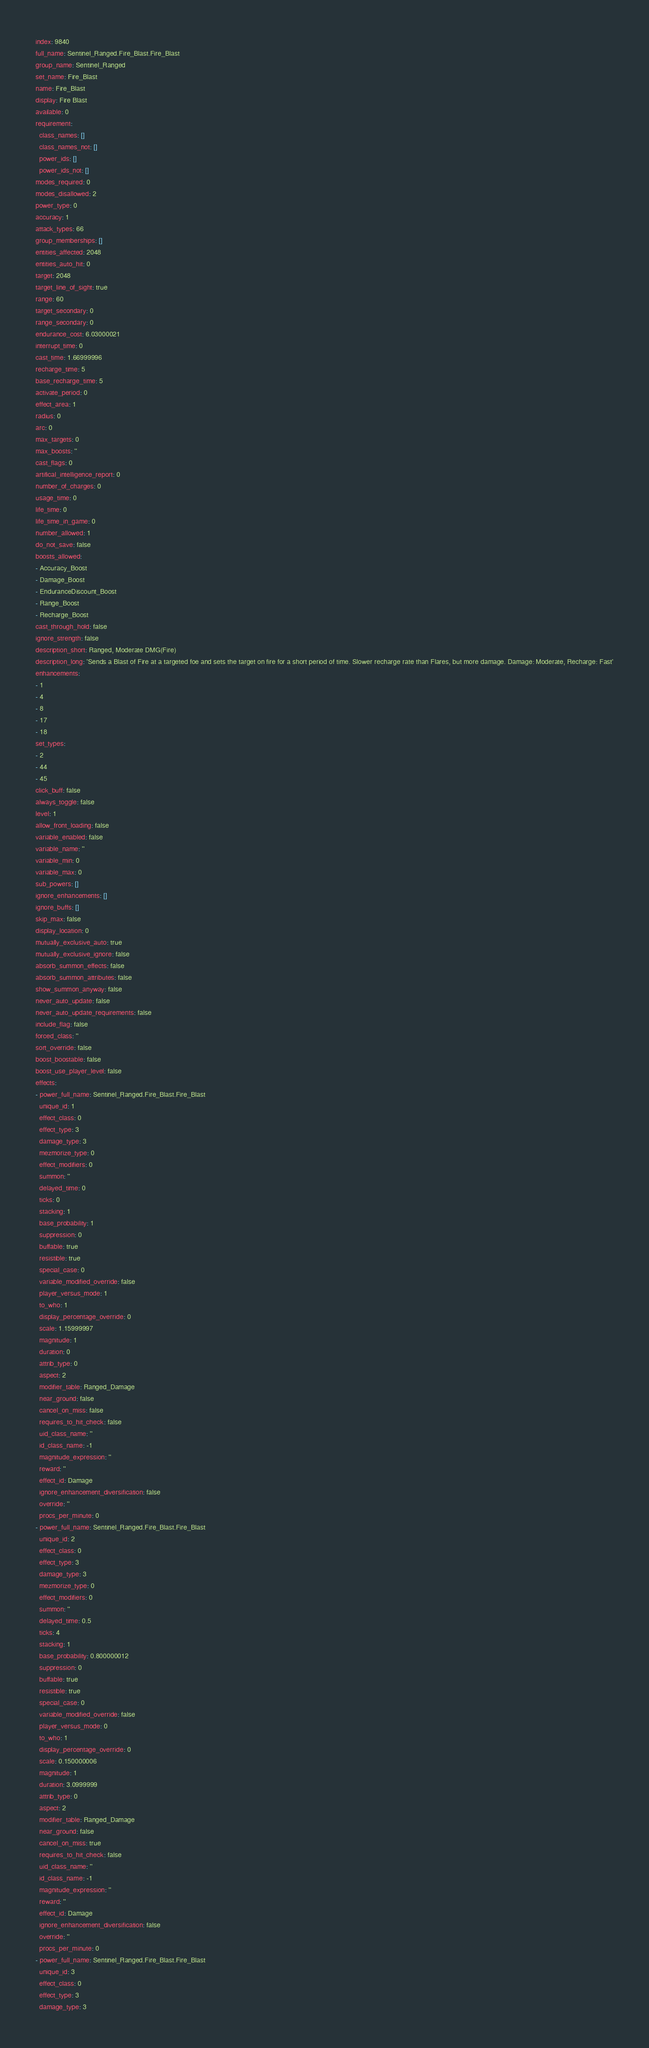Convert code to text. <code><loc_0><loc_0><loc_500><loc_500><_YAML_>index: 9840
full_name: Sentinel_Ranged.Fire_Blast.Fire_Blast
group_name: Sentinel_Ranged
set_name: Fire_Blast
name: Fire_Blast
display: Fire Blast
available: 0
requirement:
  class_names: []
  class_names_not: []
  power_ids: []
  power_ids_not: []
modes_required: 0
modes_disallowed: 2
power_type: 0
accuracy: 1
attack_types: 66
group_memberships: []
entities_affected: 2048
entities_auto_hit: 0
target: 2048
target_line_of_sight: true
range: 60
target_secondary: 0
range_secondary: 0
endurance_cost: 6.03000021
interrupt_time: 0
cast_time: 1.66999996
recharge_time: 5
base_recharge_time: 5
activate_period: 0
effect_area: 1
radius: 0
arc: 0
max_targets: 0
max_boosts: ''
cast_flags: 0
artifical_intelligence_report: 0
number_of_charges: 0
usage_time: 0
life_time: 0
life_time_in_game: 0
number_allowed: 1
do_not_save: false
boosts_allowed:
- Accuracy_Boost
- Damage_Boost
- EnduranceDiscount_Boost
- Range_Boost
- Recharge_Boost
cast_through_hold: false
ignore_strength: false
description_short: Ranged, Moderate DMG(Fire)
description_long: 'Sends a Blast of Fire at a targeted foe and sets the target on fire for a short period of time. Slower recharge rate than Flares, but more damage. Damage: Moderate, Recharge: Fast'
enhancements:
- 1
- 4
- 8
- 17
- 18
set_types:
- 2
- 44
- 45
click_buff: false
always_toggle: false
level: 1
allow_front_loading: false
variable_enabled: false
variable_name: ''
variable_min: 0
variable_max: 0
sub_powers: []
ignore_enhancements: []
ignore_buffs: []
skip_max: false
display_location: 0
mutually_exclusive_auto: true
mutually_exclusive_ignore: false
absorb_summon_effects: false
absorb_summon_attributes: false
show_summon_anyway: false
never_auto_update: false
never_auto_update_requirements: false
include_flag: false
forced_class: ''
sort_override: false
boost_boostable: false
boost_use_player_level: false
effects:
- power_full_name: Sentinel_Ranged.Fire_Blast.Fire_Blast
  unique_id: 1
  effect_class: 0
  effect_type: 3
  damage_type: 3
  mezmorize_type: 0
  effect_modifiers: 0
  summon: ''
  delayed_time: 0
  ticks: 0
  stacking: 1
  base_probability: 1
  suppression: 0
  buffable: true
  resistible: true
  special_case: 0
  variable_modified_override: false
  player_versus_mode: 1
  to_who: 1
  display_percentage_override: 0
  scale: 1.15999997
  magnitude: 1
  duration: 0
  attrib_type: 0
  aspect: 2
  modifier_table: Ranged_Damage
  near_ground: false
  cancel_on_miss: false
  requires_to_hit_check: false
  uid_class_name: ''
  id_class_name: -1
  magnitude_expression: ''
  reward: ''
  effect_id: Damage
  ignore_enhancement_diversification: false
  override: ''
  procs_per_minute: 0
- power_full_name: Sentinel_Ranged.Fire_Blast.Fire_Blast
  unique_id: 2
  effect_class: 0
  effect_type: 3
  damage_type: 3
  mezmorize_type: 0
  effect_modifiers: 0
  summon: ''
  delayed_time: 0.5
  ticks: 4
  stacking: 1
  base_probability: 0.800000012
  suppression: 0
  buffable: true
  resistible: true
  special_case: 0
  variable_modified_override: false
  player_versus_mode: 0
  to_who: 1
  display_percentage_override: 0
  scale: 0.150000006
  magnitude: 1
  duration: 3.0999999
  attrib_type: 0
  aspect: 2
  modifier_table: Ranged_Damage
  near_ground: false
  cancel_on_miss: true
  requires_to_hit_check: false
  uid_class_name: ''
  id_class_name: -1
  magnitude_expression: ''
  reward: ''
  effect_id: Damage
  ignore_enhancement_diversification: false
  override: ''
  procs_per_minute: 0
- power_full_name: Sentinel_Ranged.Fire_Blast.Fire_Blast
  unique_id: 3
  effect_class: 0
  effect_type: 3
  damage_type: 3</code> 